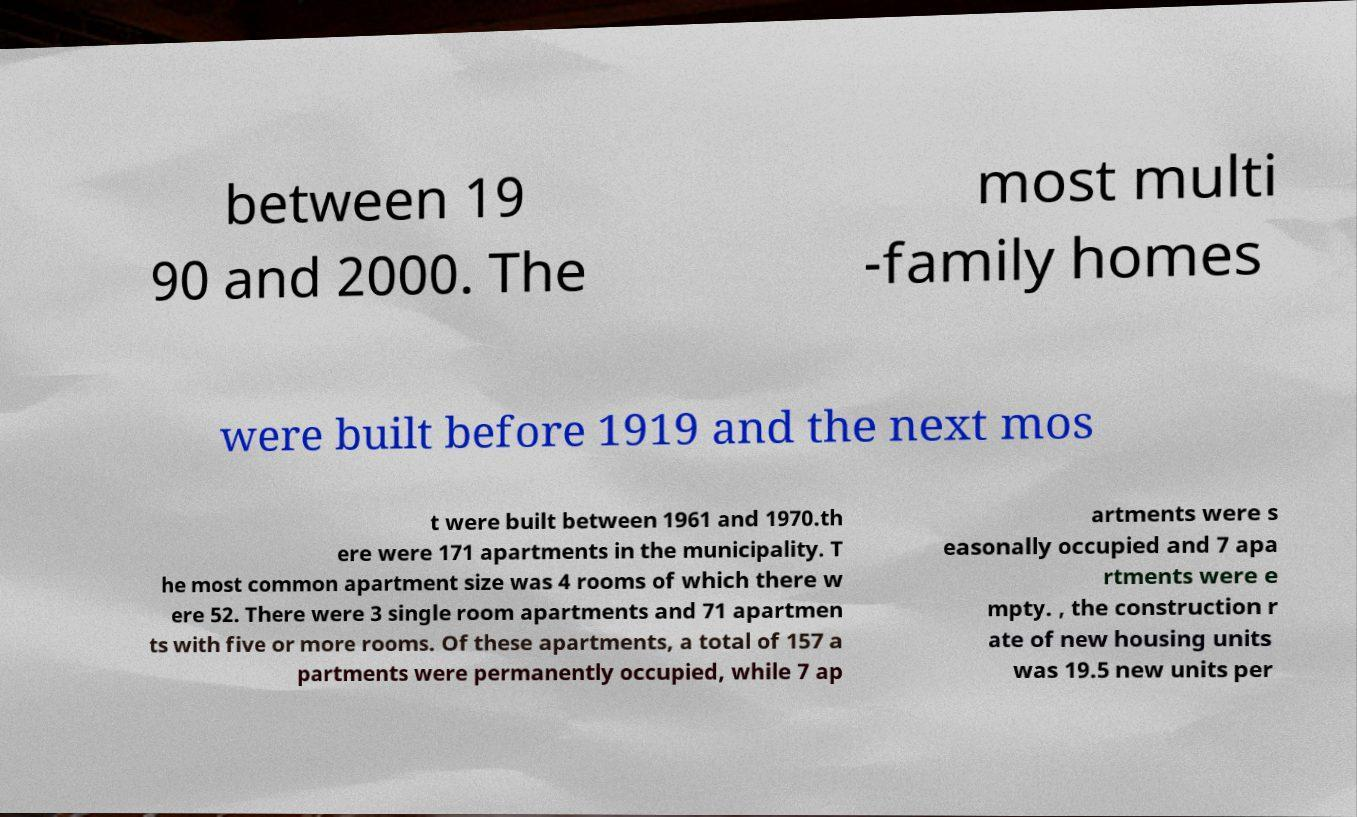There's text embedded in this image that I need extracted. Can you transcribe it verbatim? between 19 90 and 2000. The most multi -family homes were built before 1919 and the next mos t were built between 1961 and 1970.th ere were 171 apartments in the municipality. T he most common apartment size was 4 rooms of which there w ere 52. There were 3 single room apartments and 71 apartmen ts with five or more rooms. Of these apartments, a total of 157 a partments were permanently occupied, while 7 ap artments were s easonally occupied and 7 apa rtments were e mpty. , the construction r ate of new housing units was 19.5 new units per 